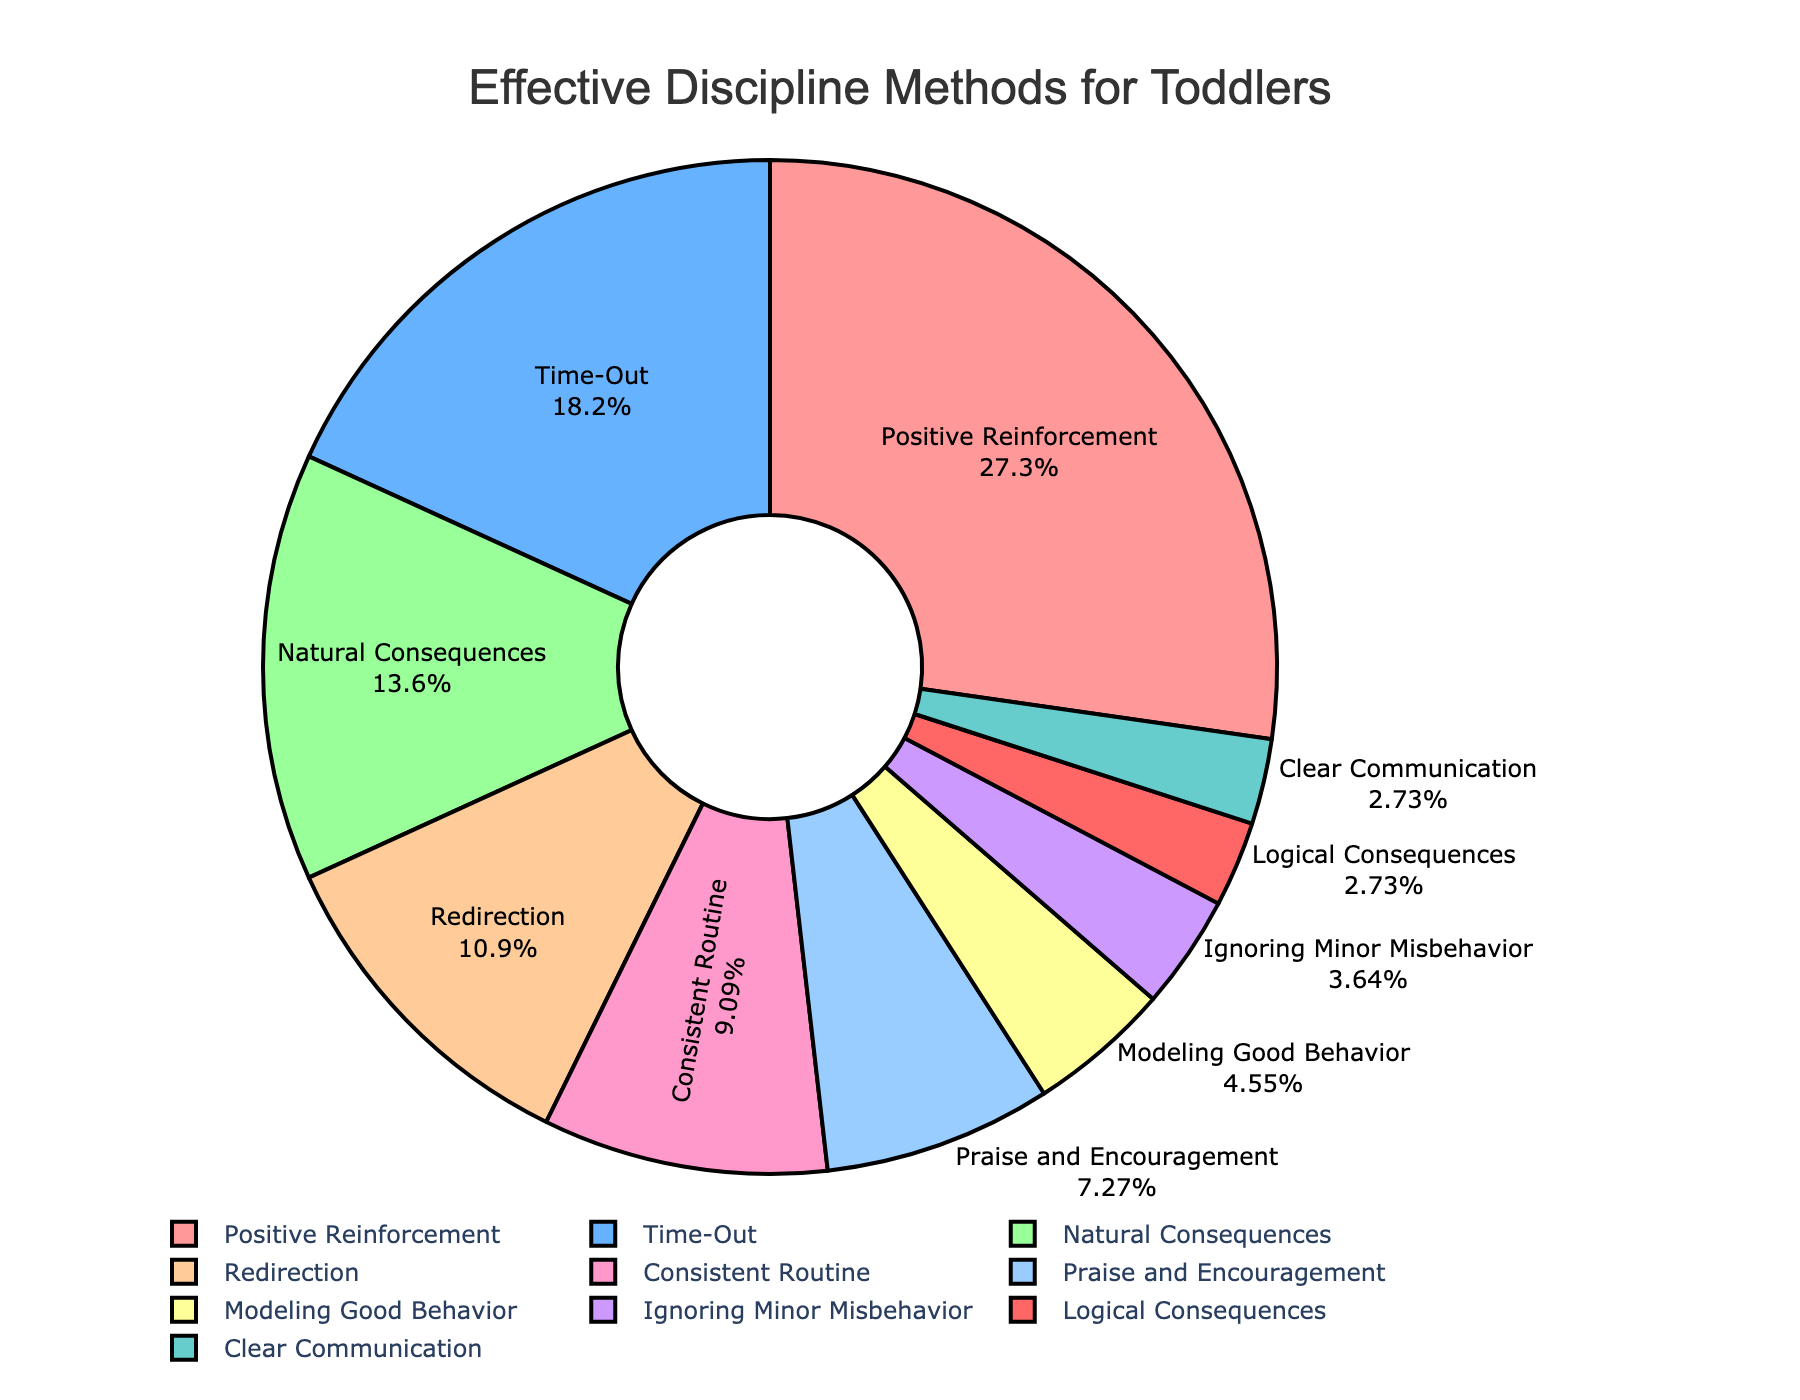What's the most common discipline method? The pie chart displays the percentages of different discipline methods. The largest section, which occupies 30%, is labeled "Positive Reinforcement." This indicates that Positive Reinforcement is the most common discipline method.
Answer: Positive Reinforcement What is the difference in percentage between "Time-Out" and "Natural Consequences"? To find the difference, subtract the percentage of "Natural Consequences" from that of "Time-Out": 20% (Time-Out) - 15% (Natural Consequences) = 5%.
Answer: 5% How many methods have a percentage above 10%? By examining the pie chart, the methods with percentages above 10% are "Positive Reinforcement" (30%), "Time-Out" (20%), and "Natural Consequences" (15%), "Redirection" (12%). There are 4 such methods.
Answer: 4 Which method occupies the smallest portion of the chart? The smallest section of the pie chart is labeled "Clear Communication," taking up only 3%.
Answer: Clear Communication Is "Praise and Encouragement" used more frequently than "Modeling Good Behavior"? "Praise and Encouragement" occupies 8% of the chart, whereas "Modeling Good Behavior" occupies 5%. Therefore, "Praise and Encouragement" is used more frequently.
Answer: Yes Combine the percentages of "Consistent Routine" and "Ignoring Minor Misbehavior". What is their total? Adding the percentages for these two methods: 10% (Consistent Routine) + 4% (Ignoring Minor Misbehavior) = 14%.
Answer: 14% Which color represents "Redirection"? The section for "Redirection" is shown in a light orange color.
Answer: Light orange How does the frequency of "Positive Reinforcement" compare to the combined total of "Natural Consequences" and "Redirection"? Combining "Natural Consequences" and "Redirection" gives 15% + 12% = 27%. "Positive Reinforcement" alone is 30%, which is higher than the combined total.
Answer: Higher 